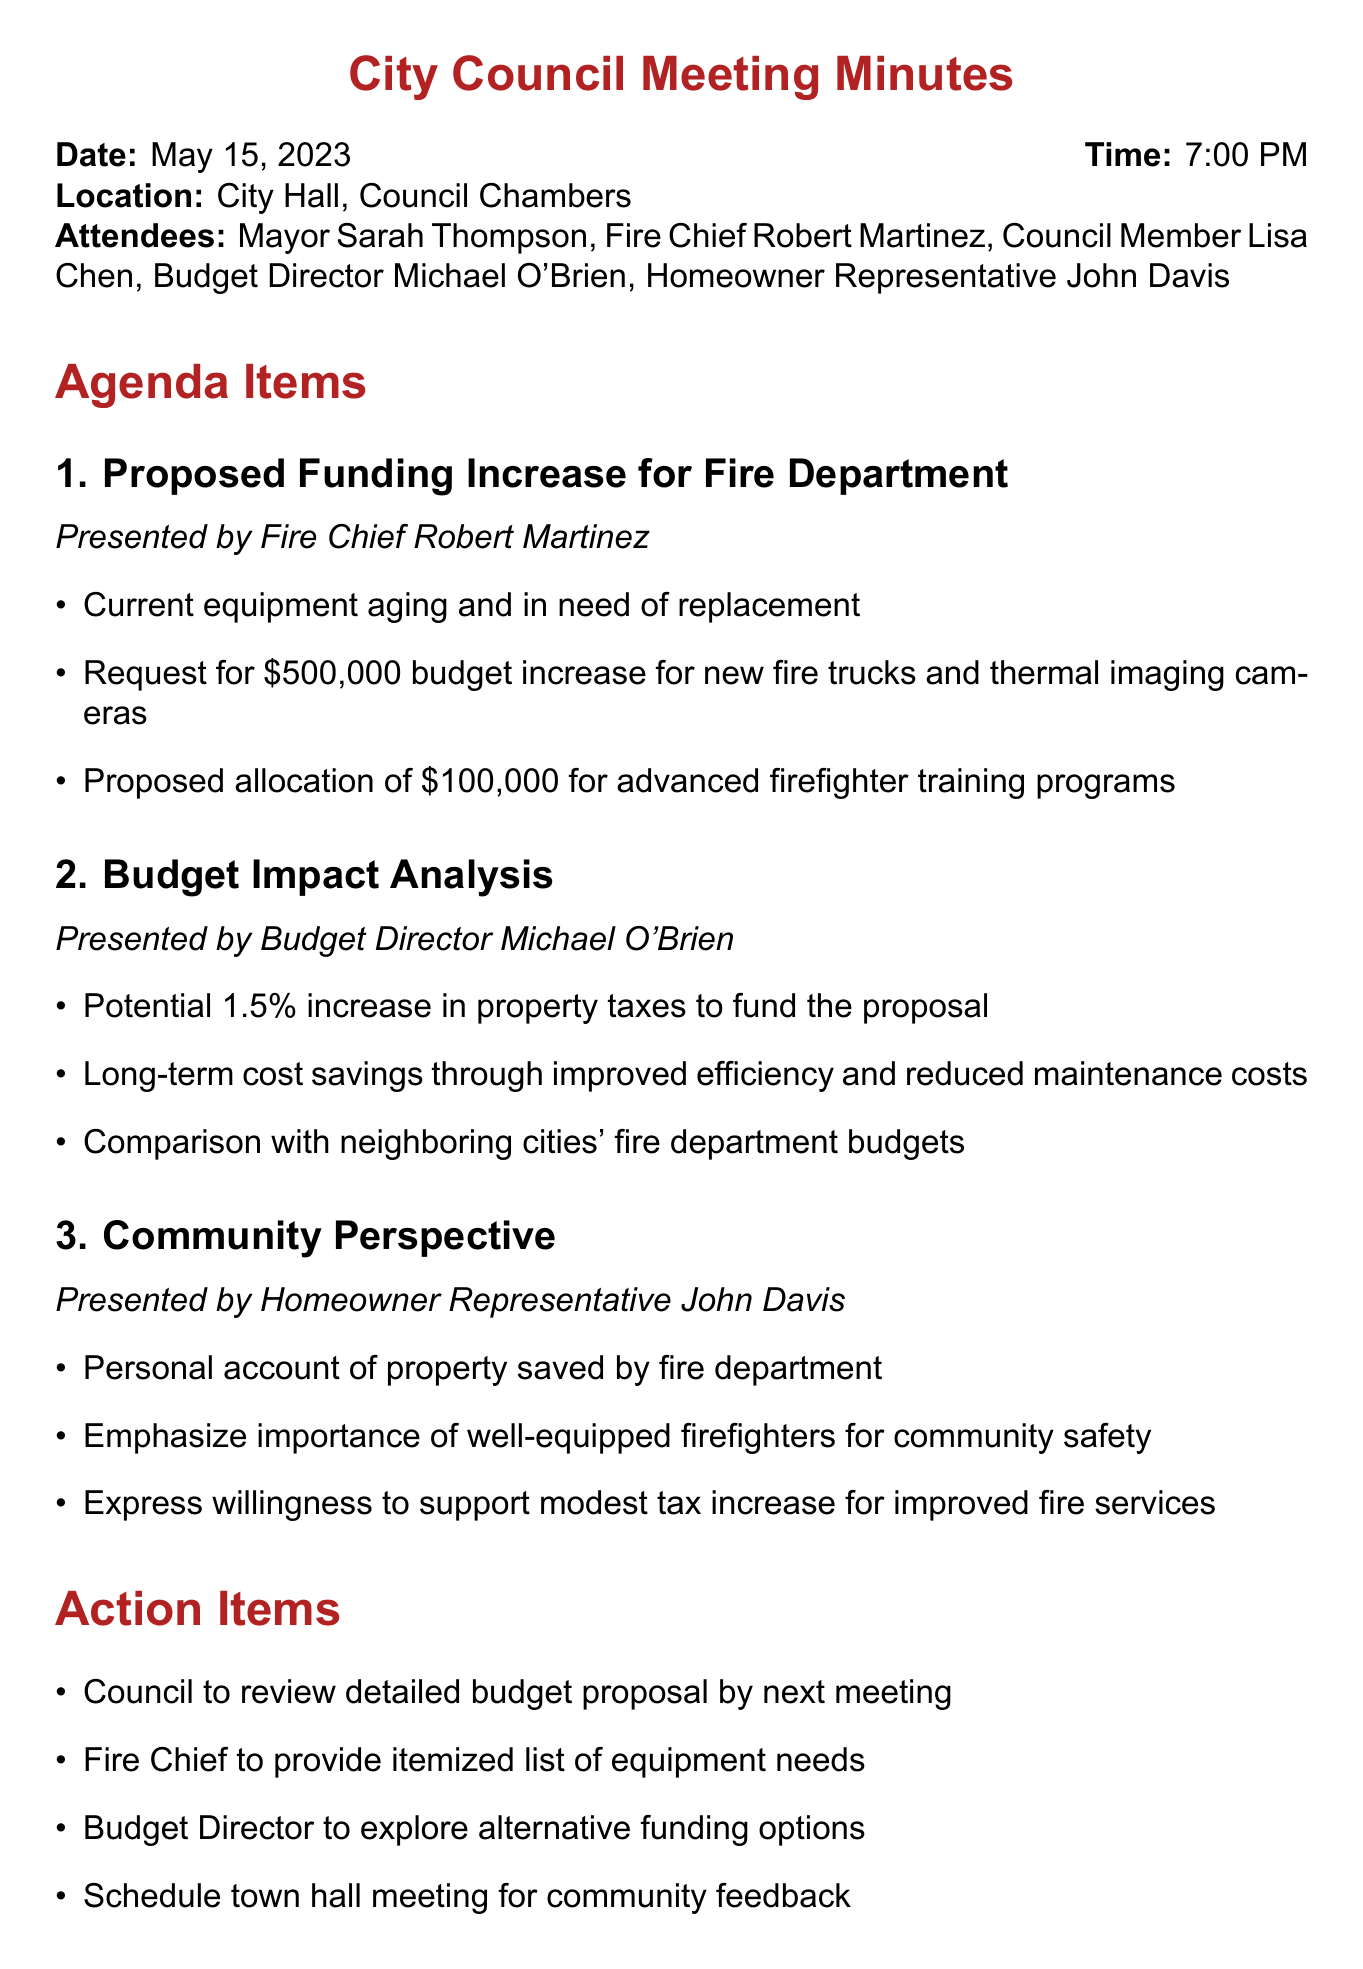What is the date of the meeting? The date of the meeting is mentioned at the beginning of the document.
Answer: May 15, 2023 Who presented the proposed funding increase for the fire department? The presenter is listed under the agenda item for the proposed funding increase.
Answer: Fire Chief Robert Martinez What is the budget increase requested for new fire trucks and thermal imaging cameras? The amount requested is specified in the key points of the agenda item.
Answer: $500,000 What is the potential percentage increase in property taxes to fund the proposal? The percentage is provided in the budget impact analysis section of the document.
Answer: 1.5% What was the personal account shared by the homeowner representative? The homeowner representative provided a specific experience related to the fire department during the community perspective discussion.
Answer: Property saved by fire department What action item involves community feedback? The action items listed include specific tasks to be done after the meeting.
Answer: Schedule town hall meeting for community feedback When is the voting date for the proposal? The voting date appears in the next steps section of the minutes.
Answer: June 1, 2023 What type of training program funding is proposed? The type of training program is mentioned in the key points for the funding increase.
Answer: Advanced firefighter training programs Who emphasized the importance of well-equipped firefighters for community safety? This information is derived from the community perspective item in the agenda.
Answer: Homeowner Representative John Davis 